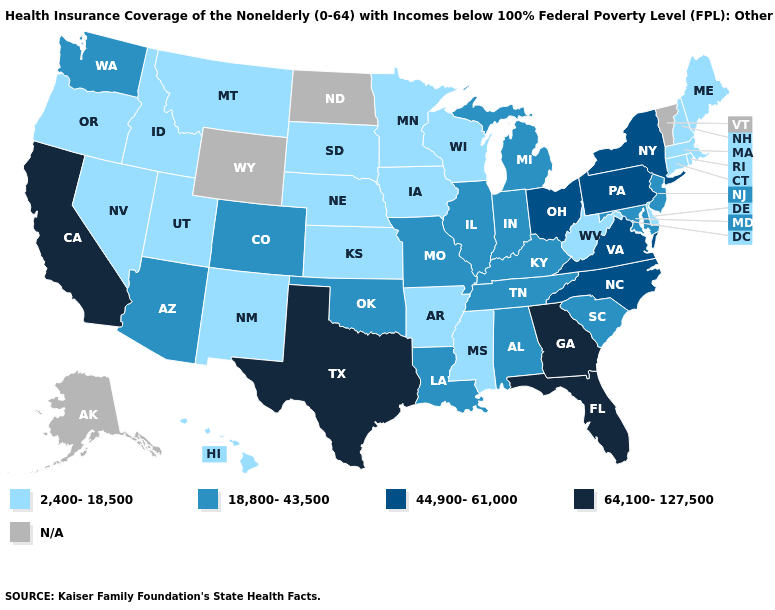Name the states that have a value in the range 64,100-127,500?
Write a very short answer. California, Florida, Georgia, Texas. What is the value of Nebraska?
Short answer required. 2,400-18,500. Does Washington have the lowest value in the West?
Keep it brief. No. Name the states that have a value in the range 64,100-127,500?
Answer briefly. California, Florida, Georgia, Texas. Which states have the lowest value in the Northeast?
Be succinct. Connecticut, Maine, Massachusetts, New Hampshire, Rhode Island. What is the value of North Carolina?
Keep it brief. 44,900-61,000. Name the states that have a value in the range 18,800-43,500?
Concise answer only. Alabama, Arizona, Colorado, Illinois, Indiana, Kentucky, Louisiana, Maryland, Michigan, Missouri, New Jersey, Oklahoma, South Carolina, Tennessee, Washington. What is the value of Oklahoma?
Keep it brief. 18,800-43,500. What is the value of New Mexico?
Concise answer only. 2,400-18,500. What is the value of New Hampshire?
Keep it brief. 2,400-18,500. Does North Carolina have the lowest value in the South?
Be succinct. No. Name the states that have a value in the range 44,900-61,000?
Answer briefly. New York, North Carolina, Ohio, Pennsylvania, Virginia. Name the states that have a value in the range 64,100-127,500?
Answer briefly. California, Florida, Georgia, Texas. 